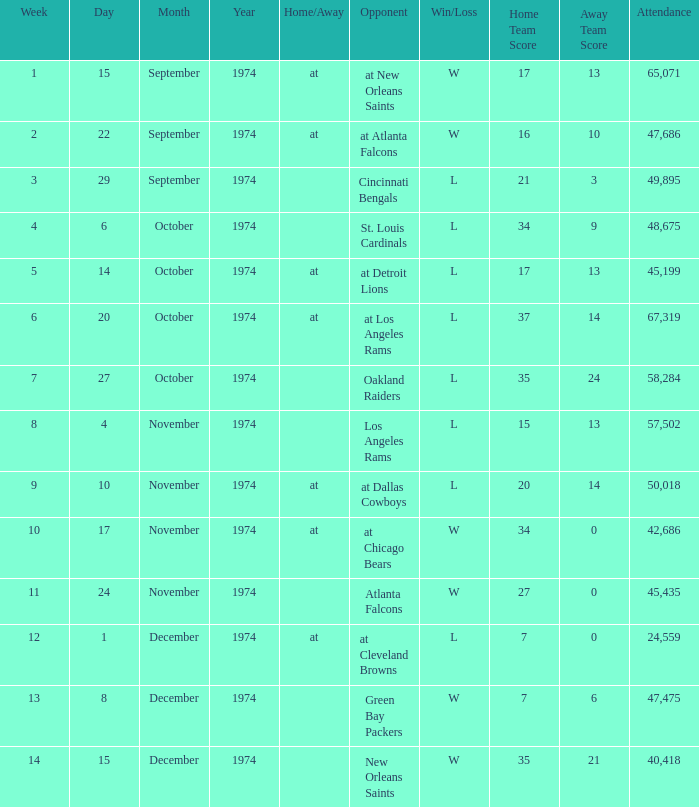What was the average attendance for games played at Atlanta Falcons? 47686.0. 